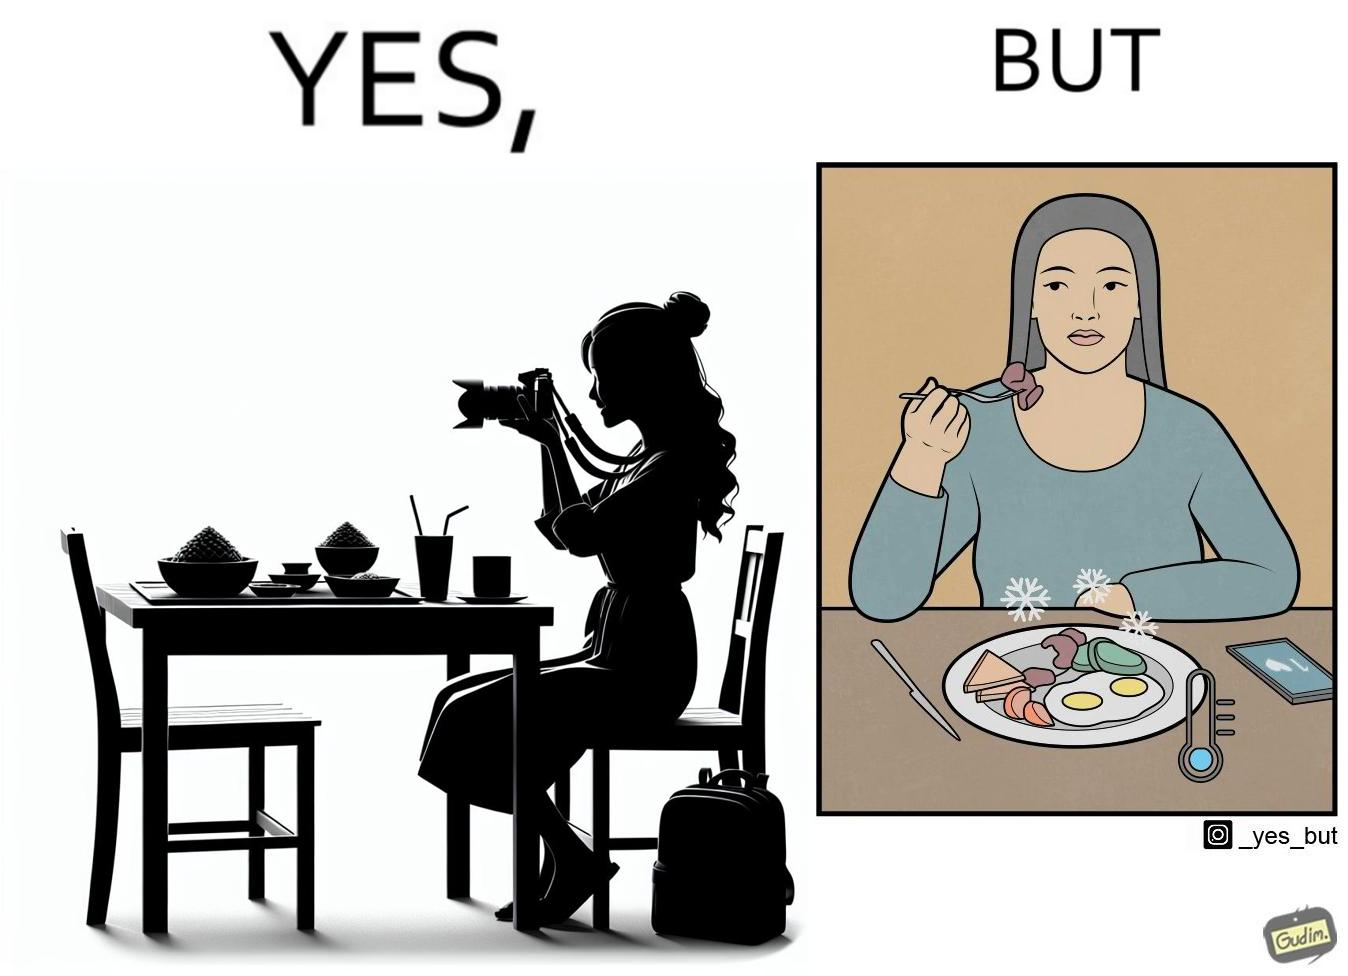What is the satirical meaning behind this image? The images are funny since they show how a woman chooses to spend time clicking pictures of her food and by the time she is done, the food is already cold and not as appetizing as it was 